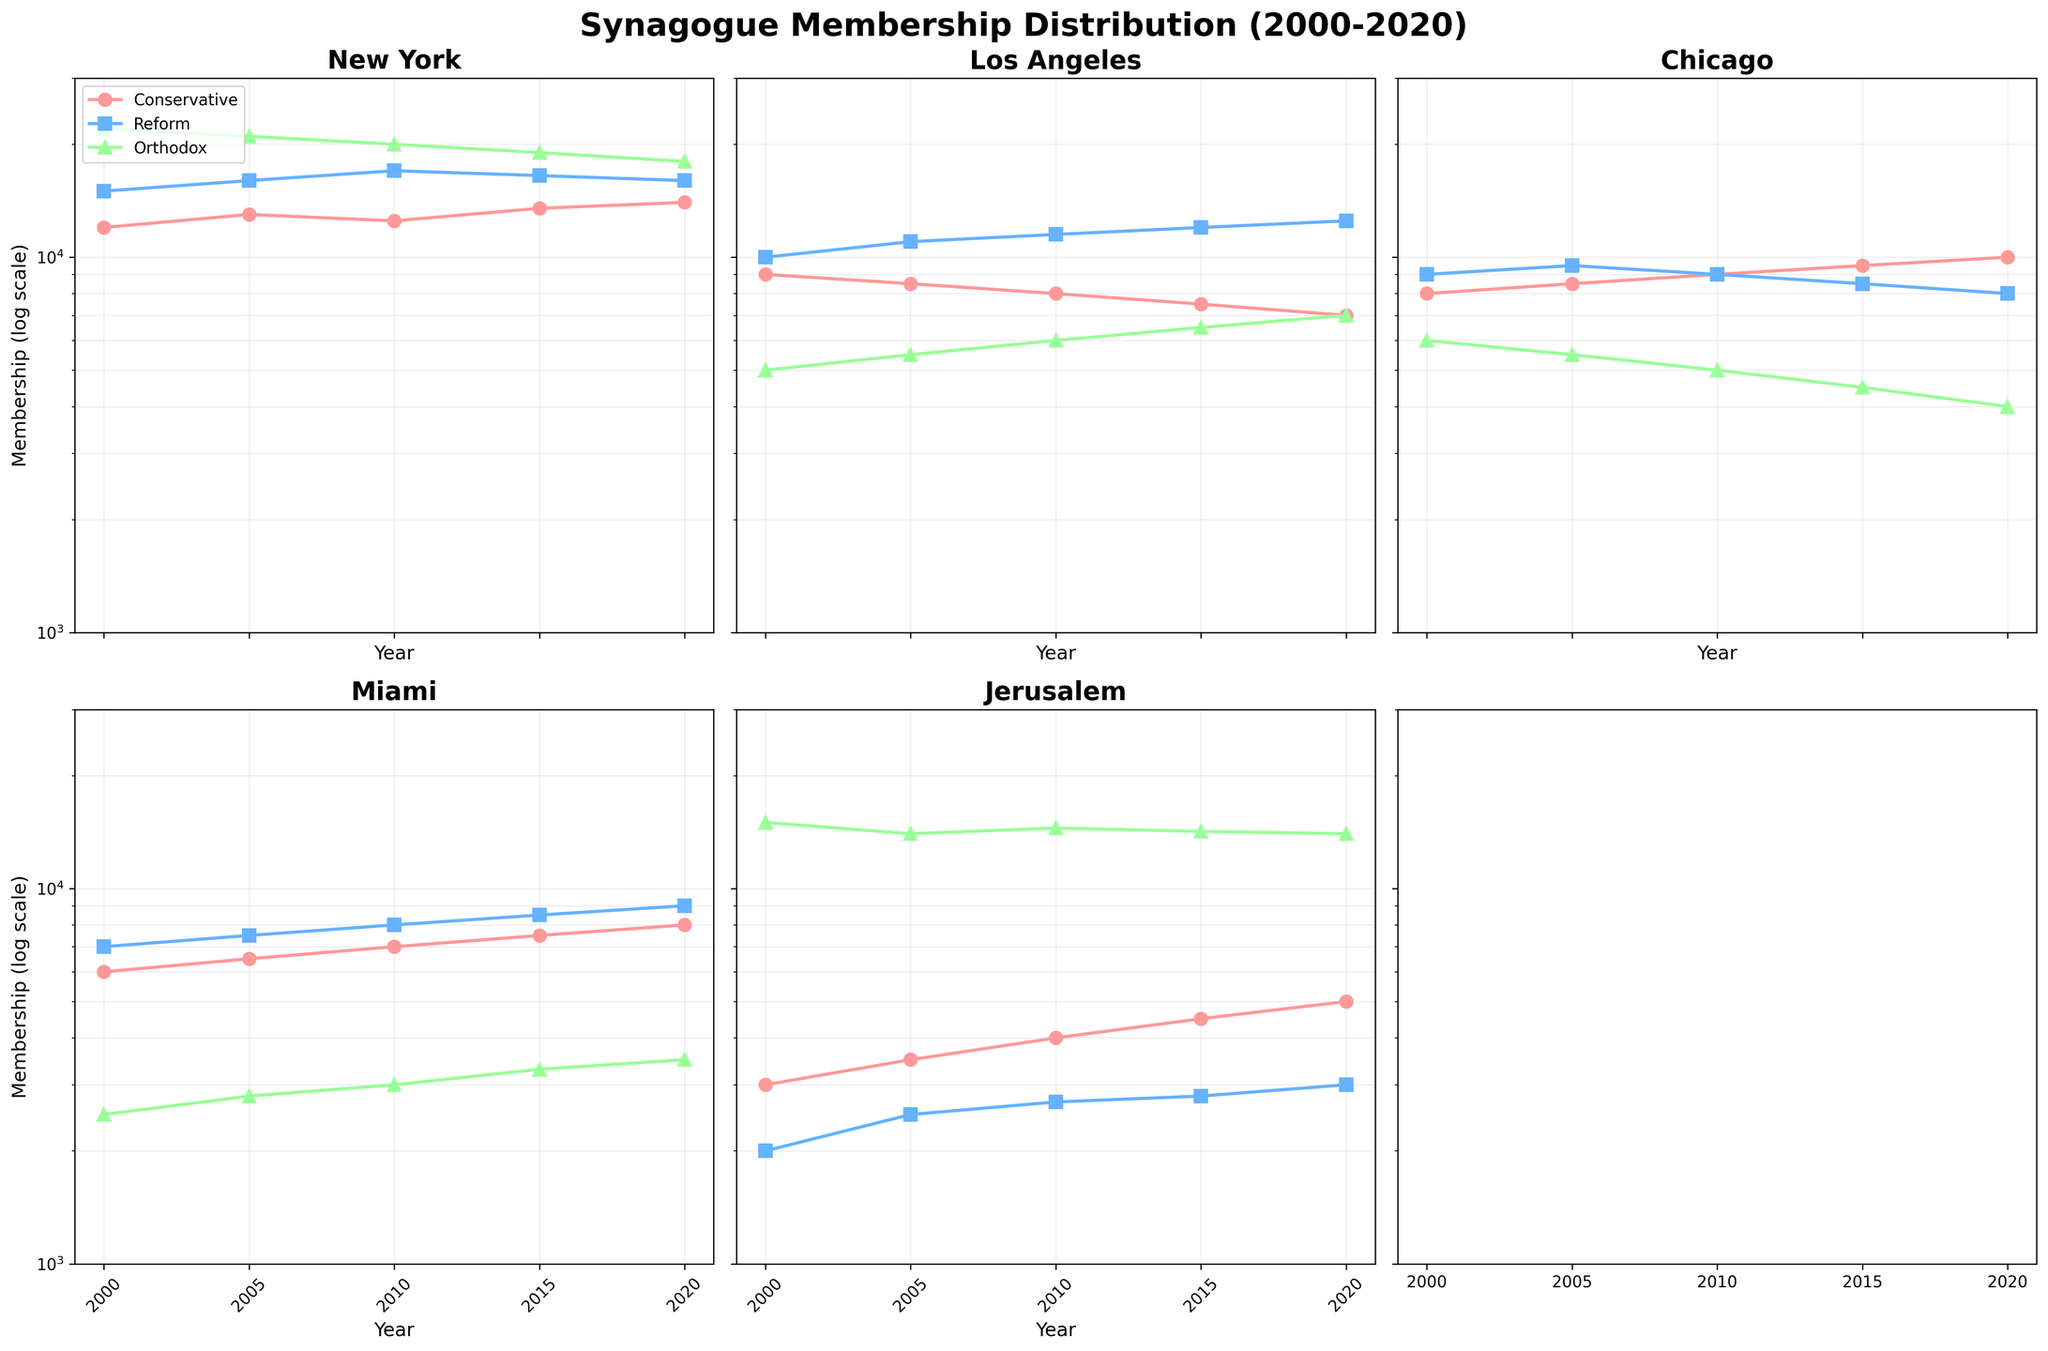Which city has the highest Orthodox membership in 2020? From the plot, the highest Orthodox membership in 2020 is clearly in Jerusalem as it far exceeds the other cities.
Answer: Jerusalem What is the overall trend for Reform synagogue memberships in New York from 2000 to 2020? Observing the New York plot for the green line representing Reform membership, it starts at 15,000 in 2000, rises to 17,000 in 2010, and then declines to 16,000 by 2020. This shows an initial increase followed by a decrease.
Answer: Initial increase, then decrease Which city shows the largest decline in Orthodox membership over the 20-year span? By examining each subplot, it is evident that New York shows the largest decline in Orthodox membership, from 22,000 in 2000 to 18,000 in 2020.
Answer: New York In which city and for which denomination does membership remain relatively stable throughout the years? Jerusalem's Orthodox membership remains relatively stable between 2000 and 2020, fluctuating only slightly around 14,000-15,000.
Answer: Jerusalem, Orthodox How does the Conservative membership trend in Chicago compare to that in Los Angeles from 2000 to 2020? Looking at the subplots, Chicago's Conservative membership increases steadily from 8,000 in 2000 to 10,000 in 2020, whereas Los Angeles' Conservative membership declines from 9,000 in 2000 to 7,000 in 2020.
Answer: Chicago increases, Los Angeles decreases What year marks the highest Reform membership in Miami? The highest Reform membership in Miami is observed in 2020, with memberships reaching 9,000, as indicated by the peak in the green line for that subplot.
Answer: 2020 How does the growth rate of Conservative membership in Miami compare to the drop in Conservative membership in New York from 2000 to 2020? Miami shows a growth in Conservative membership from 6,000 in 2000 to 8,000 in 2020 (an increase of 2,000), while New York shows a slight increase from 12,000 in 2000 to 14,000 in 2020 (an increase of 2,000). Thus, the growth rates are quite similar.
Answer: Similar growth rates Which city has the lowest membership across all denominations in 2000, and what denomination is it? The plot shows that the lowest membership in 2000 is in Miami for the Orthodox denomination, with a membership of 2,500.
Answer: Miami, Orthodox 